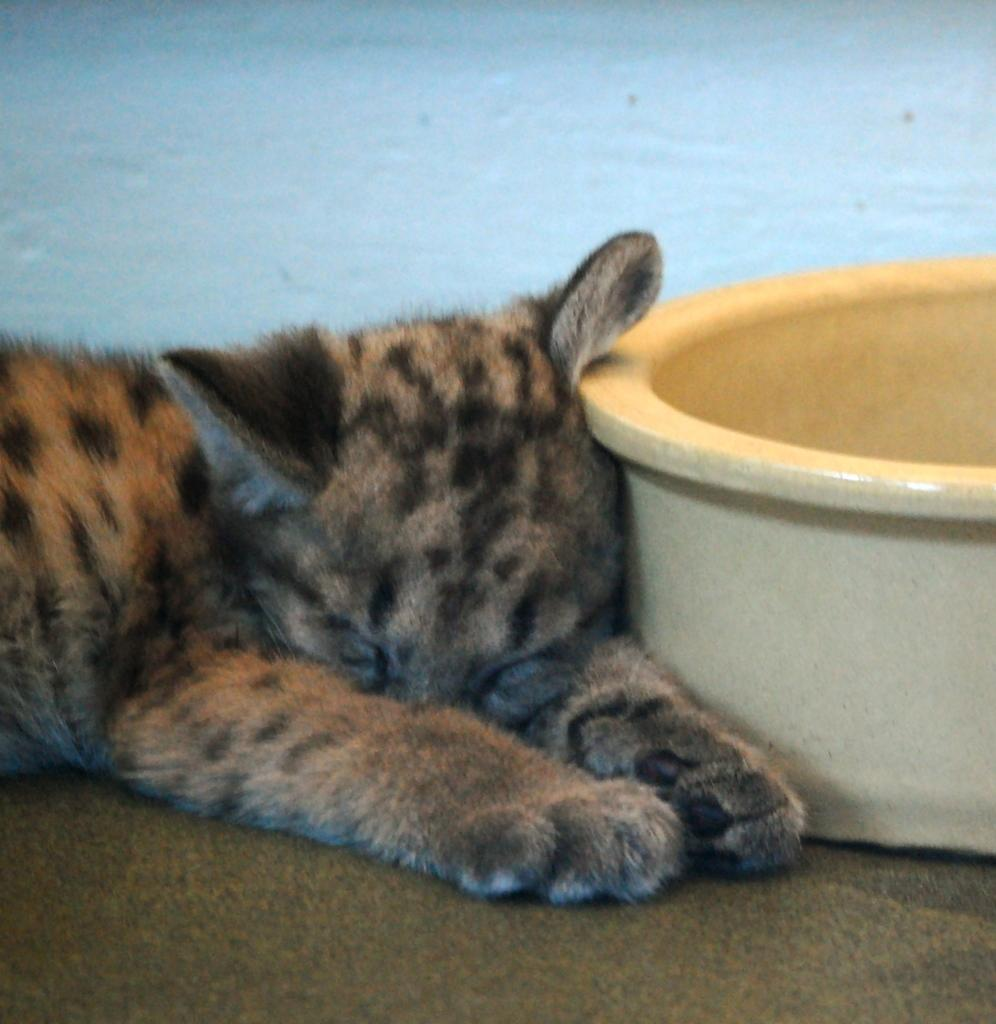What is in the bowl that is visible in the image? There is no information about the contents of the bowl in the provided facts. What type of surface is visible in the image? There is a carpet on the surface in the image. What is the cat doing in the image? The cat is sleeping in the image. Where is the cat located in relation to the wall in the image? The cat is near a wall in the image. What type of sock is the cat wearing in the image? There is no mention of a sock or any clothing on the cat in the provided facts. What is the cat's fear of in the image? There is no information about the cat's fears in the provided facts. 